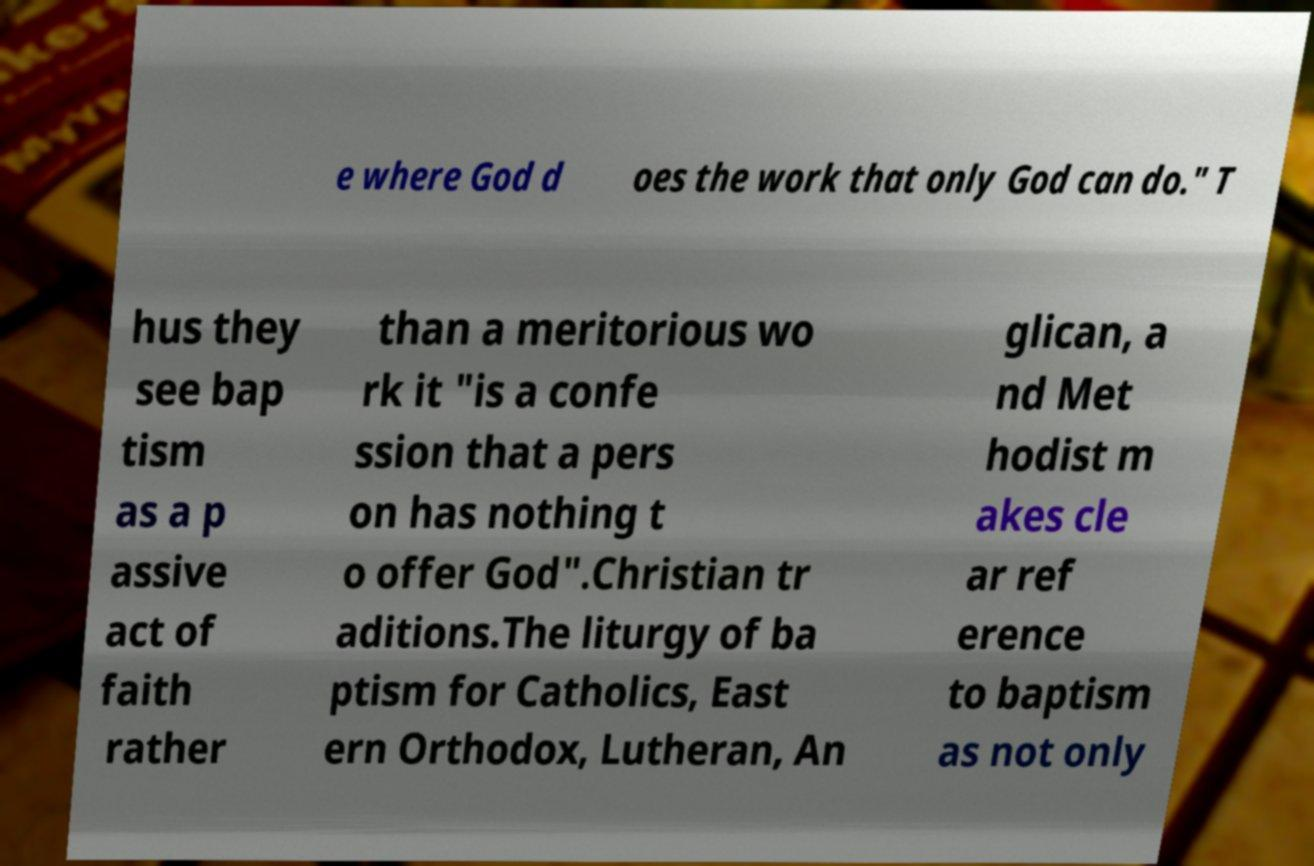Can you accurately transcribe the text from the provided image for me? e where God d oes the work that only God can do." T hus they see bap tism as a p assive act of faith rather than a meritorious wo rk it "is a confe ssion that a pers on has nothing t o offer God".Christian tr aditions.The liturgy of ba ptism for Catholics, East ern Orthodox, Lutheran, An glican, a nd Met hodist m akes cle ar ref erence to baptism as not only 